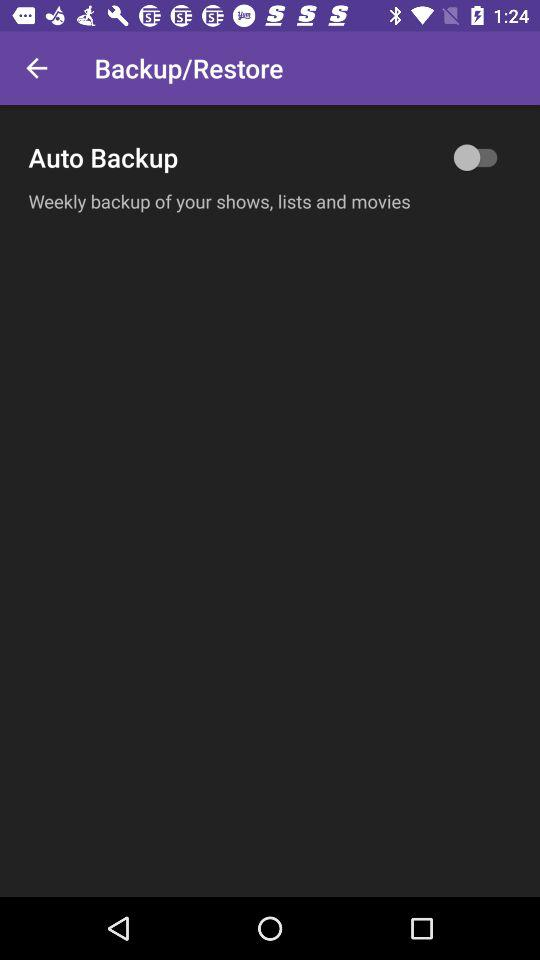What is the status of the "Auto Backup" button? The status is off. 